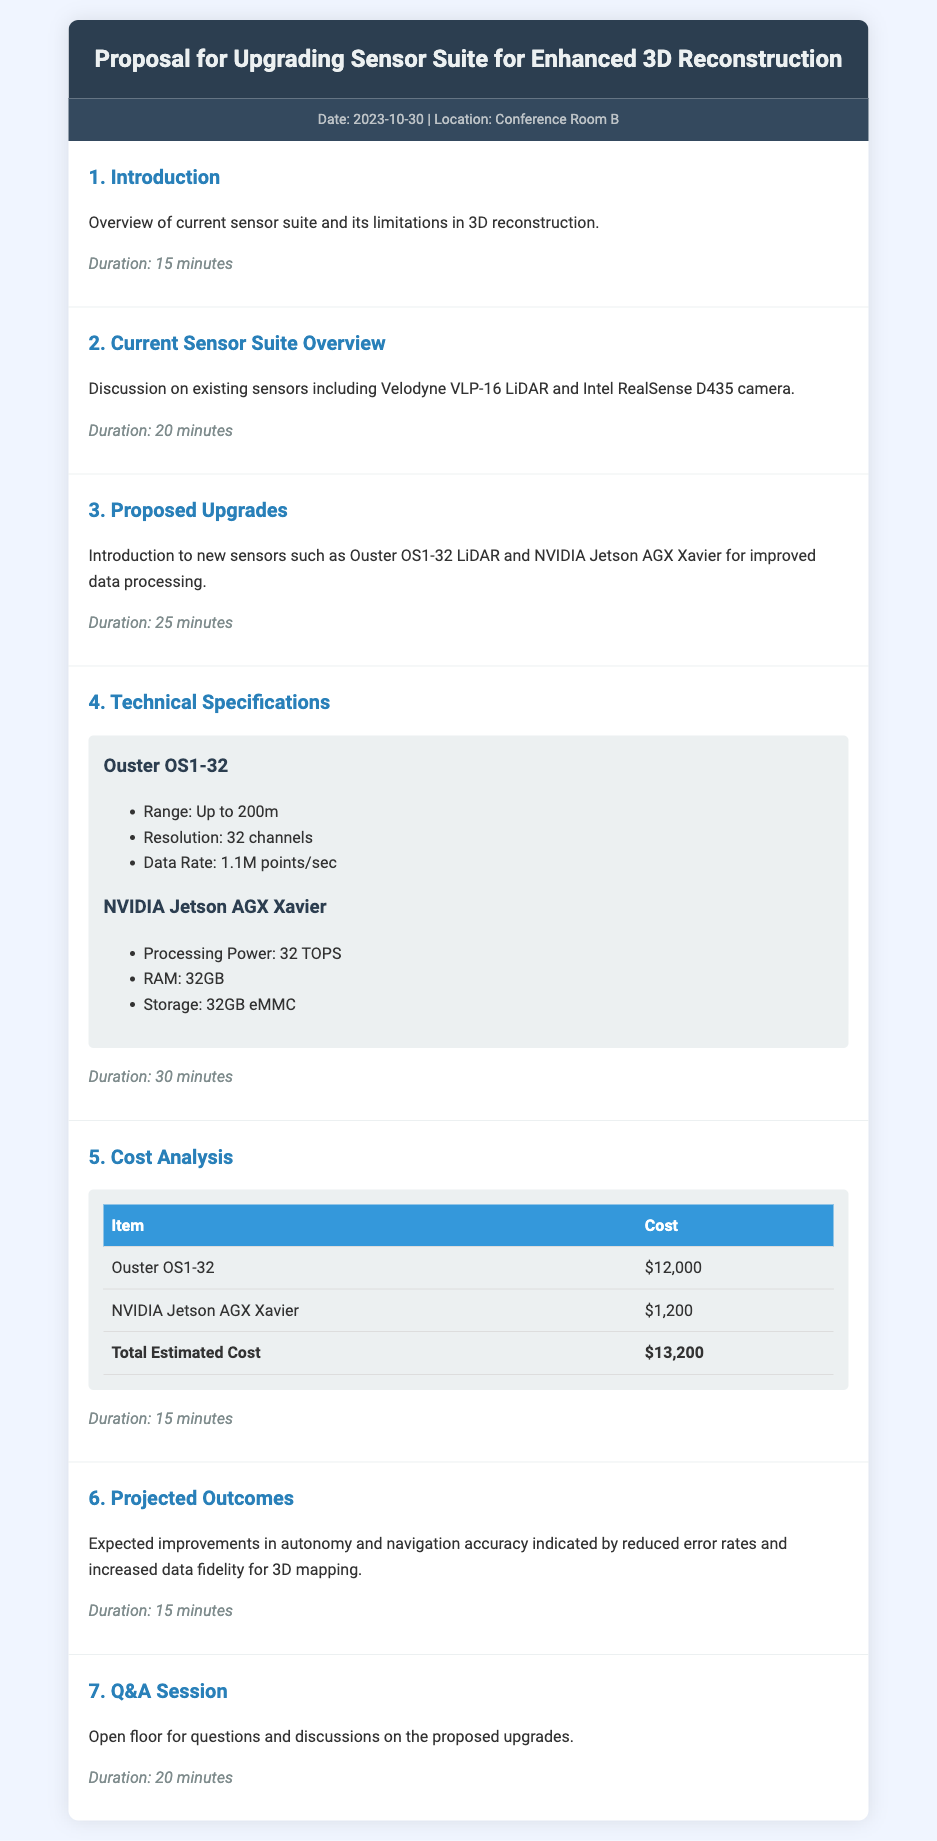What is the date of the proposal? The date of the proposal is mentioned in the meta-info section of the document.
Answer: 2023-10-30 What is the total estimated cost of the upgrades? The total estimated cost is calculated based on the costs of the individual items listed in the cost analysis section.
Answer: $13,200 What is the processing power of the NVIDIA Jetson AGX Xavier? The processing power is specified under the technical specifications section for the NVIDIA Jetson AGX Xavier.
Answer: 32 TOPS What improvement is expected in autonomy after upgrades? Expected improvements are described in the projected outcomes section concerning autonomy and navigation accuracy.
Answer: Reduced error rates How long is the Q&A session scheduled for? The duration of the Q&A session is indicated at the end of the agenda.
Answer: 20 minutes What sensor is being replaced by the Ouster OS1-32? The current sensor suite overview mentions existing sensors that the new upgrades will replace.
Answer: Velodyne VLP-16 LiDAR How many channels does the Ouster OS1-32 LiDAR have? The number of channels is detailed in the technical specifications section for Ouster OS1-32.
Answer: 32 channels What is the RAM capacity of the NVIDIA Jetson AGX Xavier? The RAM capacity is listed among the specifications for the NVIDIA Jetson AGX Xavier.
Answer: 32GB 